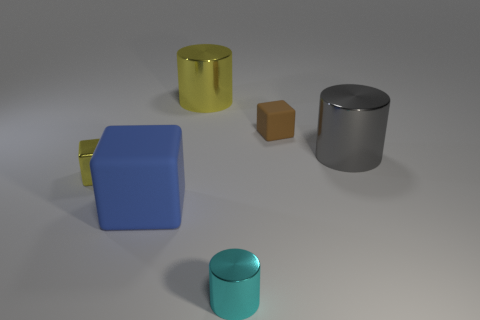What material do these objects appear to be made of? The objects in the image seem to be made of different types of materials. The blue cube and the small brown block have a matte finish suggesting a possible plastic or painted wood construction, while the silver cylinder and teal cylinder appear metallic due to their reflective surface. The yellow mug has a glossy finish that is characteristic of ceramic or painted metal. 